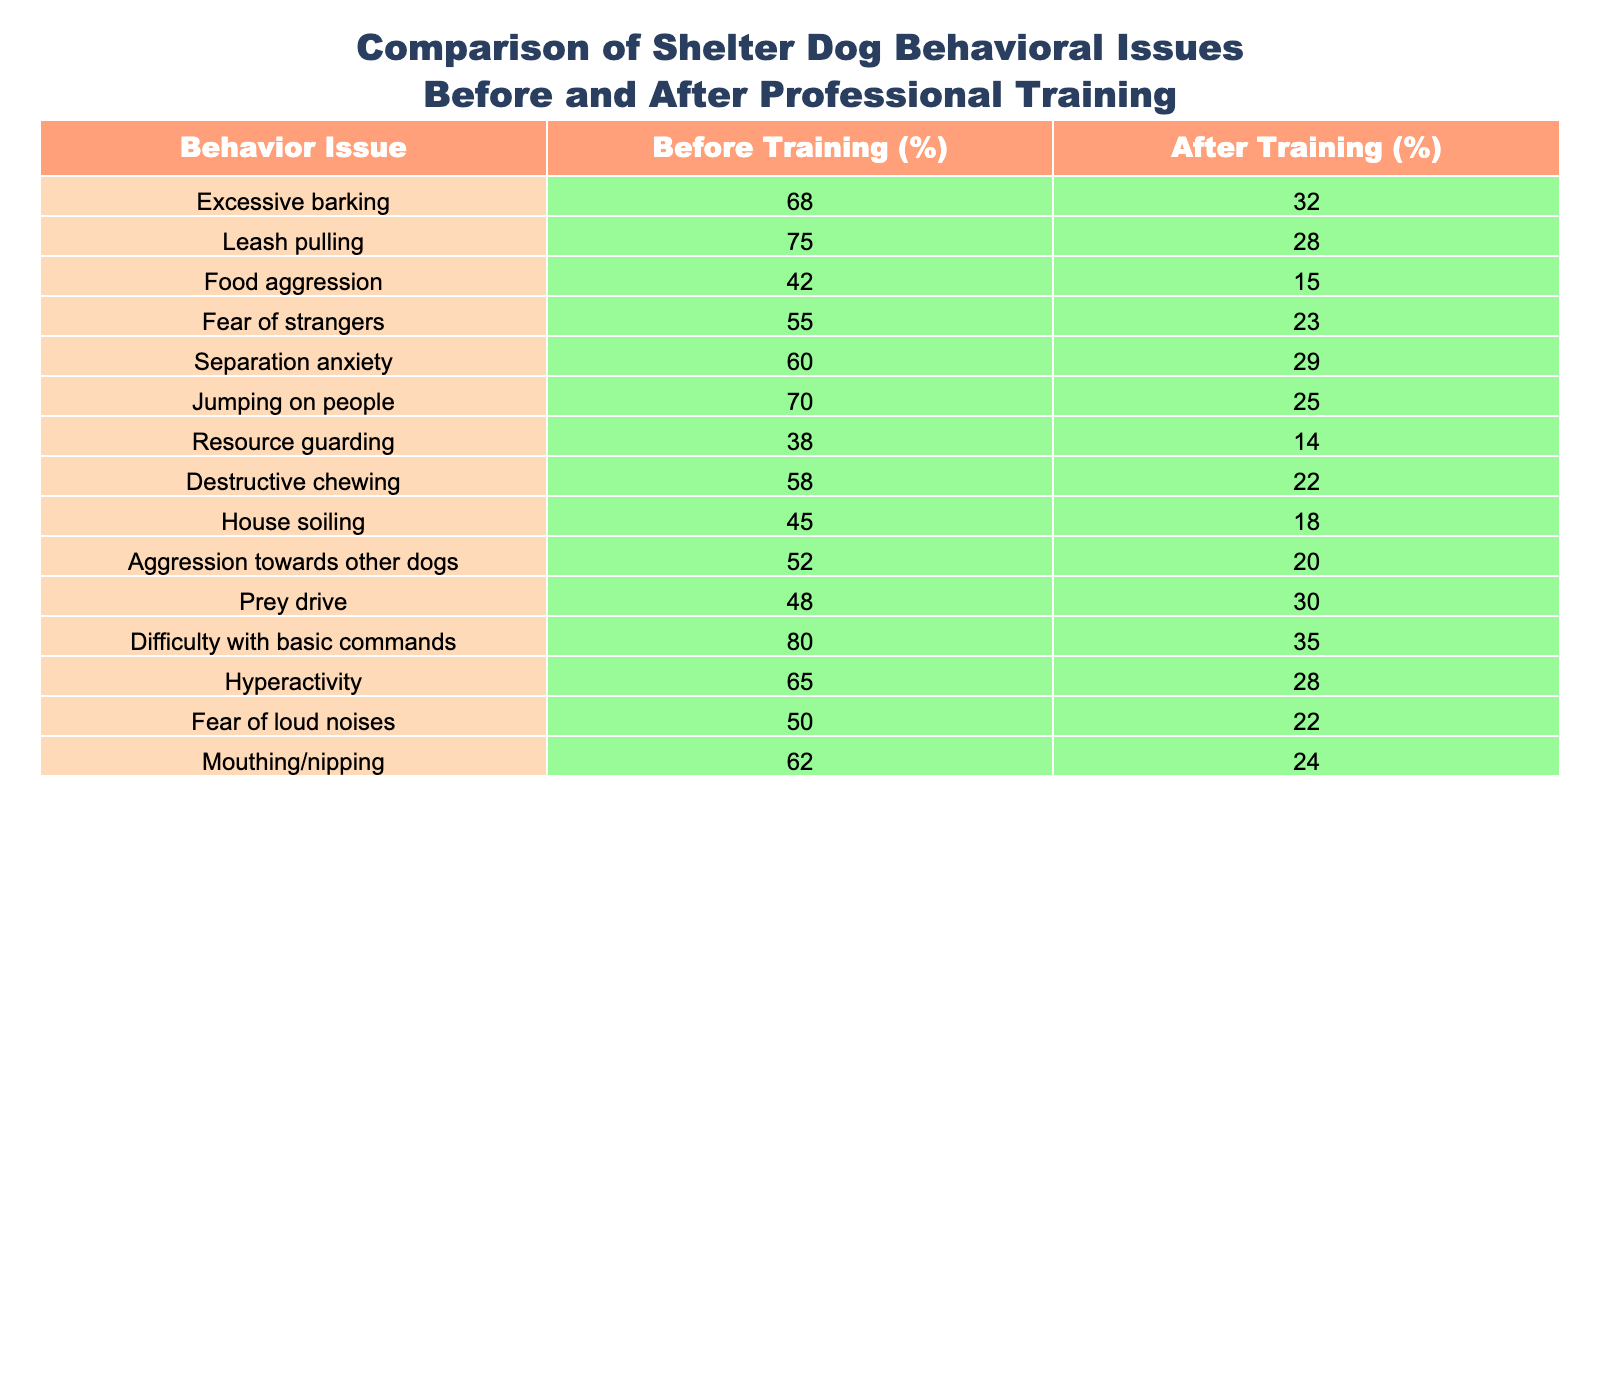What percentage of dogs had difficulty with basic commands before training? The table shows that 80% of dogs had difficulty with basic commands before training, as indicated in the "Before Training (%)" column.
Answer: 80% What was the percentage reduction in food aggression after training? The percentage of food aggression before training was 42%, and after training, it was 15%. The reduction is calculated as 42% - 15% = 27%.
Answer: 27% Is it true that separation anxiety was more common than jumping on people before training? Before training, separation anxiety was at 60% while jumping on people was at 70%. Since 60% is less than 70%, the statement is false.
Answer: No What behavior issue showed the largest percentage decrease after training? By comparing the differences in percentages for each behavior before and after training, food aggression showed the largest decrease: 42% (before) to 15% (after), which is a decrease of 27%.
Answer: Food aggression What is the average percentage of fear-related issues (fear of strangers and fear of loud noises) before training? The fear of strangers was 55% and fear of loud noises was 50%. The average is calculated as (55 + 50) / 2 = 52.5%.
Answer: 52.5% How many behavior issues showed more than a 30% reduction after training? By checking each behavior in the table, the following issues showed more than a 30% reduction: excessive barking (36%), leash pulling (47%), food aggression (27%), and jumping on people (45%). This totals 4 behavior issues with reductions greater than 30%.
Answer: 4 Was resource guarding one of the top three issues by percentage before training? Resource guarding had a percentage of 38% before training. The top three issues are excessive barking (68%), leash pulling (75%), and difficulty with basic commands (80%). Since 38% is not among these top three, the answer is no.
Answer: No What is the percentage difference in resource guarding before and after training? The percentage for resource guarding was 38% before and 14% after training. The difference is calculated as 38% - 14% = 24%.
Answer: 24% 